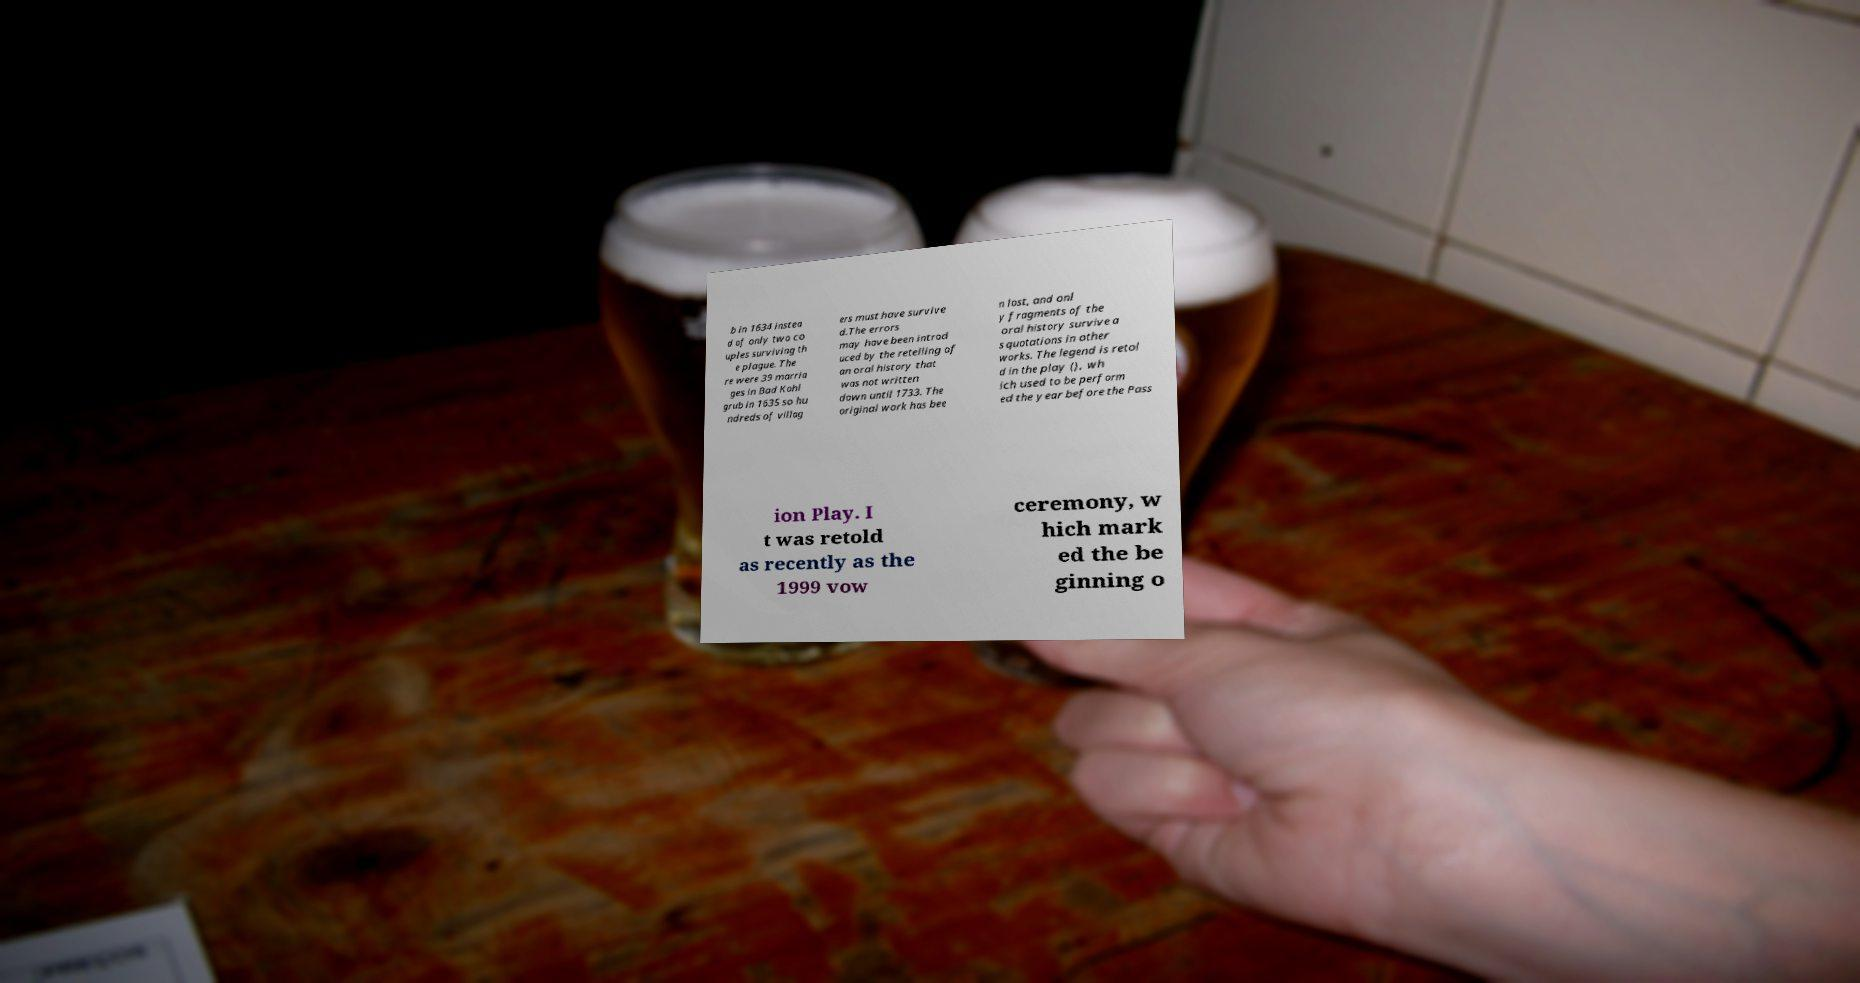Could you assist in decoding the text presented in this image and type it out clearly? b in 1634 instea d of only two co uples surviving th e plague. The re were 39 marria ges in Bad Kohl grub in 1635 so hu ndreds of villag ers must have survive d.The errors may have been introd uced by the retelling of an oral history that was not written down until 1733. The original work has bee n lost, and onl y fragments of the oral history survive a s quotations in other works. The legend is retol d in the play (), wh ich used to be perform ed the year before the Pass ion Play. I t was retold as recently as the 1999 vow ceremony, w hich mark ed the be ginning o 